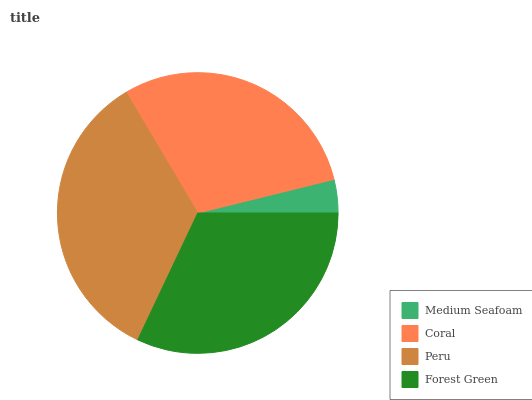Is Medium Seafoam the minimum?
Answer yes or no. Yes. Is Peru the maximum?
Answer yes or no. Yes. Is Coral the minimum?
Answer yes or no. No. Is Coral the maximum?
Answer yes or no. No. Is Coral greater than Medium Seafoam?
Answer yes or no. Yes. Is Medium Seafoam less than Coral?
Answer yes or no. Yes. Is Medium Seafoam greater than Coral?
Answer yes or no. No. Is Coral less than Medium Seafoam?
Answer yes or no. No. Is Forest Green the high median?
Answer yes or no. Yes. Is Coral the low median?
Answer yes or no. Yes. Is Medium Seafoam the high median?
Answer yes or no. No. Is Forest Green the low median?
Answer yes or no. No. 